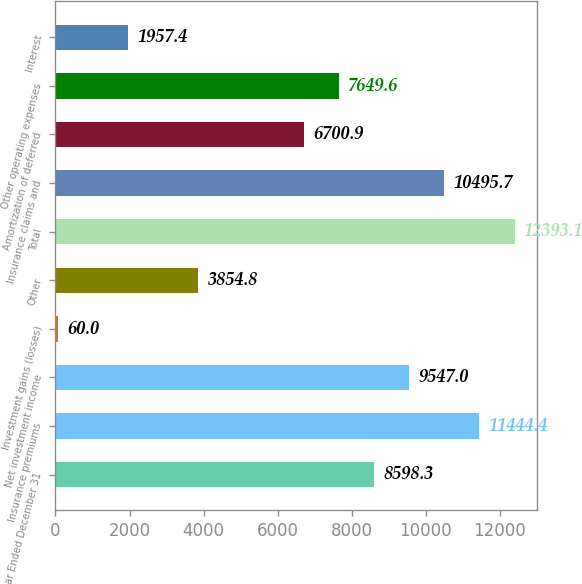<chart> <loc_0><loc_0><loc_500><loc_500><bar_chart><fcel>Year Ended December 31<fcel>Insurance premiums<fcel>Net investment income<fcel>Investment gains (losses)<fcel>Other<fcel>Total<fcel>Insurance claims and<fcel>Amortization of deferred<fcel>Other operating expenses<fcel>Interest<nl><fcel>8598.3<fcel>11444.4<fcel>9547<fcel>60<fcel>3854.8<fcel>12393.1<fcel>10495.7<fcel>6700.9<fcel>7649.6<fcel>1957.4<nl></chart> 